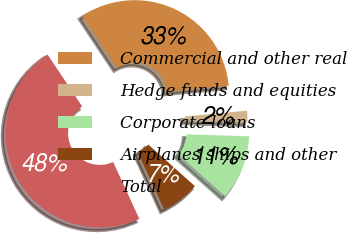Convert chart. <chart><loc_0><loc_0><loc_500><loc_500><pie_chart><fcel>Commercial and other real<fcel>Hedge funds and equities<fcel>Corporate loans<fcel>Airplanes ships and other<fcel>Total<nl><fcel>32.85%<fcel>2.0%<fcel>11.1%<fcel>6.55%<fcel>47.5%<nl></chart> 